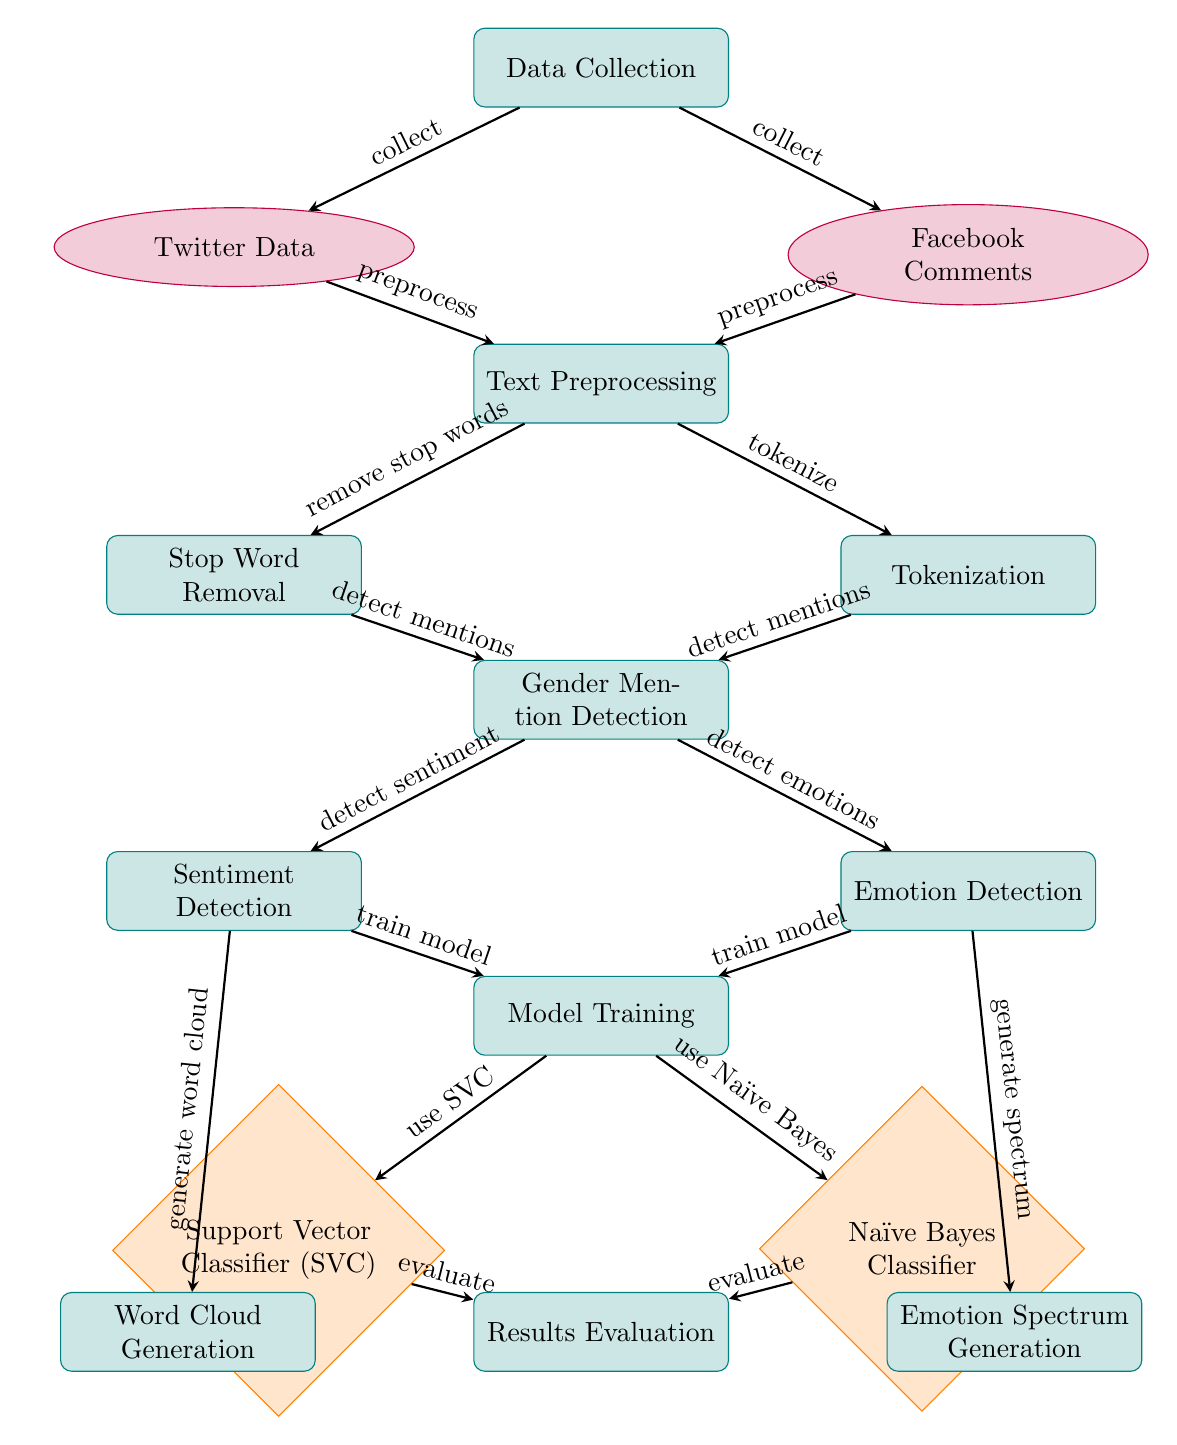What are the sources of data collection in the diagram? The diagram has two sources listed under the data collection node: Twitter Data and Facebook Comments, indicating the platforms used for data gathering.
Answer: Twitter Data, Facebook Comments What processes follow text preprocessing in the diagram? After the text preprocessing step, gender mention detection occurs, which leads to two further processes: sentiment detection and emotion detection.
Answer: Gender Mention Detection, Sentiment Detection, Emotion Detection How many models are trained in the model training stage? The model training node shows two different algorithms being utilized: Support Vector Classifier (SVC) and Naïve Bayes Classifier, indicating that two models are trained in this stage.
Answer: 2 What is the first step in processing data according to the diagram? The initial step outlined in the diagram is data collection, where data is gathered from Twitter and Facebook forms before any processing begins.
Answer: Data Collection Which process generates a word cloud according to the diagram? The diagram indicates that sentiment detection is the process that leads to word cloud generation, showcasing its role in visualizing predominant sentiments.
Answer: Sentiment Detection What is the relationship between gender mention detection and model training? Gender mention detection is a precursor step that feeds into model training, signifying that the outcomes of gender mentions are critical for the training of the models.
Answer: Precursor What are the outputs of the results evaluation in the diagram? According to the diagram, the results evaluation process leads to two outputs: word cloud generation and emotion spectrum generation, indicating the result types produced by this stage.
Answer: Word Cloud Generation, Emotion Spectrum Generation What is the last process indicated in the diagram? The last process depicted in the flow is results evaluation, which synthesizes the work done through the preceding steps and assesses the outcomes of the model training.
Answer: Results Evaluation 